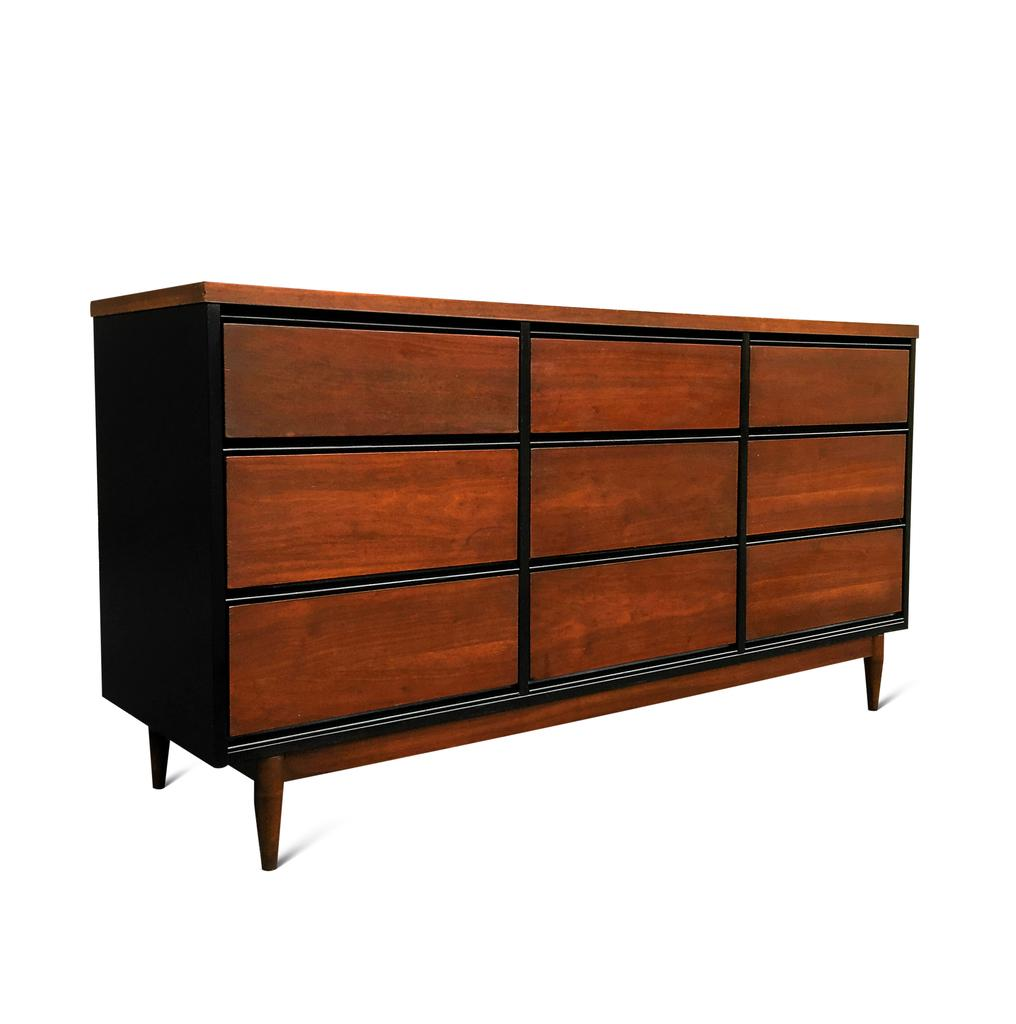What is the main object in the image? There is a brown color wooden block in the image. Can you describe the appearance of the wooden block? The wooden block is brown in color. What type of van can be seen driving through the town in the image? There is no van or town present in the image; it only features a brown color wooden block. 